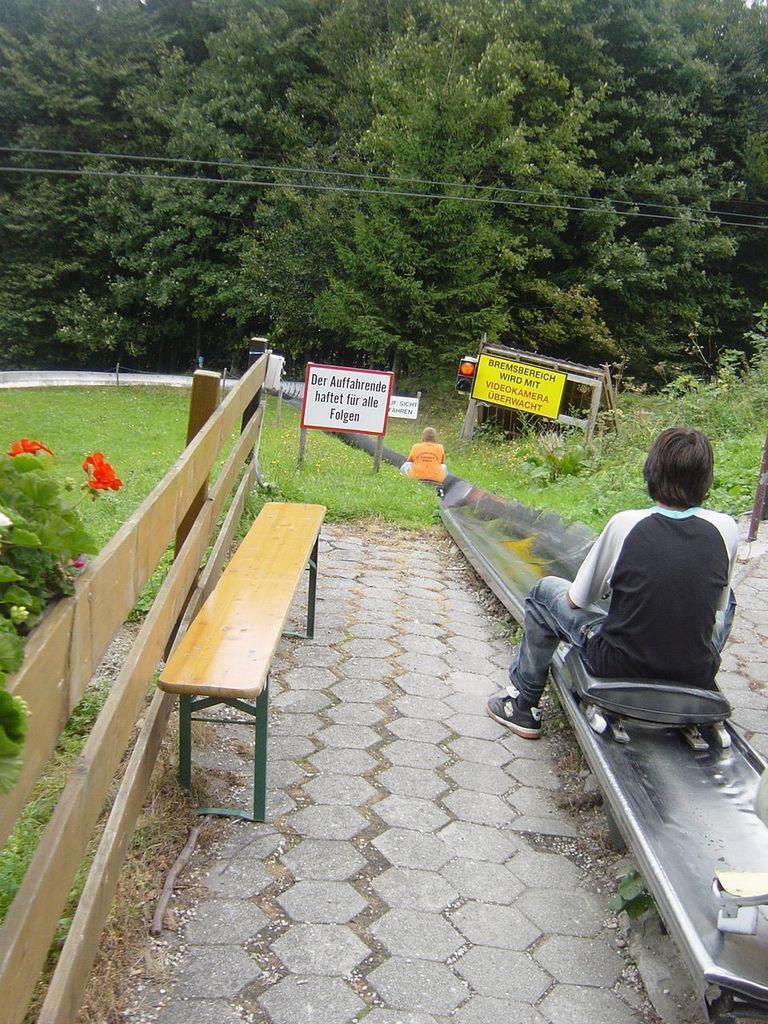Could you give a brief overview of what you see in this image? In this picture a woman is sitting on the skateboard. In the backdrop there is a bench, plants, grass, boards and trees. 